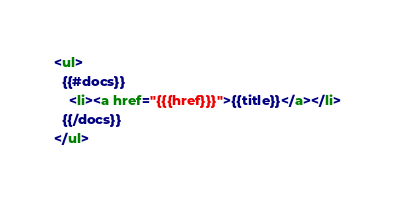<code> <loc_0><loc_0><loc_500><loc_500><_HTML_><ul>
  {{#docs}}
    <li><a href="{{{href}}}">{{title}}</a></li>
  {{/docs}}
</ul></code> 